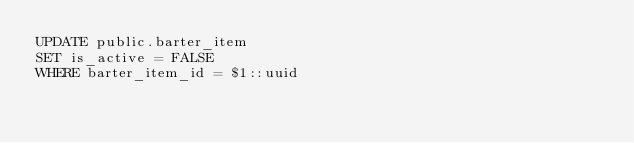Convert code to text. <code><loc_0><loc_0><loc_500><loc_500><_SQL_>UPDATE public.barter_item
SET is_active = FALSE
WHERE barter_item_id = $1::uuid
</code> 